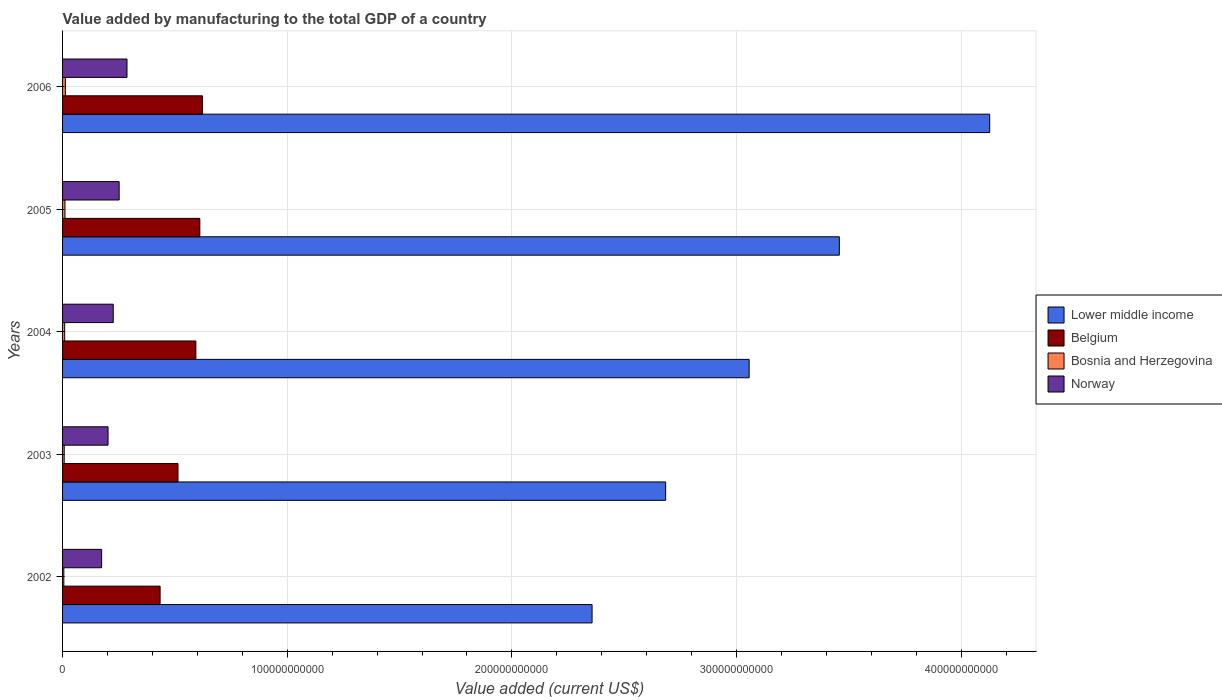Are the number of bars on each tick of the Y-axis equal?
Offer a very short reply. Yes. How many bars are there on the 3rd tick from the bottom?
Your answer should be compact. 4. In how many cases, is the number of bars for a given year not equal to the number of legend labels?
Keep it short and to the point. 0. What is the value added by manufacturing to the total GDP in Lower middle income in 2004?
Your response must be concise. 3.06e+11. Across all years, what is the maximum value added by manufacturing to the total GDP in Norway?
Your answer should be very brief. 2.87e+1. Across all years, what is the minimum value added by manufacturing to the total GDP in Bosnia and Herzegovina?
Make the answer very short. 5.59e+08. In which year was the value added by manufacturing to the total GDP in Bosnia and Herzegovina maximum?
Provide a succinct answer. 2006. What is the total value added by manufacturing to the total GDP in Norway in the graph?
Make the answer very short. 1.14e+11. What is the difference between the value added by manufacturing to the total GDP in Belgium in 2003 and that in 2006?
Your answer should be very brief. -1.09e+1. What is the difference between the value added by manufacturing to the total GDP in Norway in 2005 and the value added by manufacturing to the total GDP in Lower middle income in 2002?
Your response must be concise. -2.11e+11. What is the average value added by manufacturing to the total GDP in Bosnia and Herzegovina per year?
Offer a terse response. 9.12e+08. In the year 2004, what is the difference between the value added by manufacturing to the total GDP in Norway and value added by manufacturing to the total GDP in Belgium?
Your answer should be compact. -3.68e+1. What is the ratio of the value added by manufacturing to the total GDP in Lower middle income in 2003 to that in 2004?
Provide a short and direct response. 0.88. What is the difference between the highest and the second highest value added by manufacturing to the total GDP in Belgium?
Your response must be concise. 1.15e+09. What is the difference between the highest and the lowest value added by manufacturing to the total GDP in Lower middle income?
Ensure brevity in your answer.  1.77e+11. Is the sum of the value added by manufacturing to the total GDP in Belgium in 2003 and 2004 greater than the maximum value added by manufacturing to the total GDP in Bosnia and Herzegovina across all years?
Offer a terse response. Yes. Is it the case that in every year, the sum of the value added by manufacturing to the total GDP in Lower middle income and value added by manufacturing to the total GDP in Bosnia and Herzegovina is greater than the sum of value added by manufacturing to the total GDP in Norway and value added by manufacturing to the total GDP in Belgium?
Your answer should be compact. Yes. Are all the bars in the graph horizontal?
Your answer should be very brief. Yes. How many years are there in the graph?
Your answer should be compact. 5. What is the difference between two consecutive major ticks on the X-axis?
Offer a terse response. 1.00e+11. Does the graph contain any zero values?
Give a very brief answer. No. Where does the legend appear in the graph?
Offer a very short reply. Center right. How are the legend labels stacked?
Offer a very short reply. Vertical. What is the title of the graph?
Provide a short and direct response. Value added by manufacturing to the total GDP of a country. What is the label or title of the X-axis?
Offer a terse response. Value added (current US$). What is the Value added (current US$) of Lower middle income in 2002?
Offer a terse response. 2.36e+11. What is the Value added (current US$) of Belgium in 2002?
Keep it short and to the point. 4.34e+1. What is the Value added (current US$) in Bosnia and Herzegovina in 2002?
Offer a very short reply. 5.59e+08. What is the Value added (current US$) of Norway in 2002?
Provide a short and direct response. 1.74e+1. What is the Value added (current US$) of Lower middle income in 2003?
Your response must be concise. 2.68e+11. What is the Value added (current US$) in Belgium in 2003?
Keep it short and to the point. 5.14e+1. What is the Value added (current US$) in Bosnia and Herzegovina in 2003?
Ensure brevity in your answer.  7.27e+08. What is the Value added (current US$) of Norway in 2003?
Give a very brief answer. 2.02e+1. What is the Value added (current US$) in Lower middle income in 2004?
Provide a short and direct response. 3.06e+11. What is the Value added (current US$) of Belgium in 2004?
Provide a short and direct response. 5.93e+1. What is the Value added (current US$) in Bosnia and Herzegovina in 2004?
Ensure brevity in your answer.  9.40e+08. What is the Value added (current US$) in Norway in 2004?
Give a very brief answer. 2.26e+1. What is the Value added (current US$) of Lower middle income in 2005?
Provide a short and direct response. 3.46e+11. What is the Value added (current US$) of Belgium in 2005?
Ensure brevity in your answer.  6.11e+1. What is the Value added (current US$) in Bosnia and Herzegovina in 2005?
Your answer should be compact. 1.08e+09. What is the Value added (current US$) in Norway in 2005?
Your answer should be compact. 2.52e+1. What is the Value added (current US$) of Lower middle income in 2006?
Your answer should be very brief. 4.13e+11. What is the Value added (current US$) in Belgium in 2006?
Provide a succinct answer. 6.22e+1. What is the Value added (current US$) in Bosnia and Herzegovina in 2006?
Make the answer very short. 1.25e+09. What is the Value added (current US$) in Norway in 2006?
Give a very brief answer. 2.87e+1. Across all years, what is the maximum Value added (current US$) of Lower middle income?
Provide a short and direct response. 4.13e+11. Across all years, what is the maximum Value added (current US$) of Belgium?
Offer a terse response. 6.22e+1. Across all years, what is the maximum Value added (current US$) of Bosnia and Herzegovina?
Give a very brief answer. 1.25e+09. Across all years, what is the maximum Value added (current US$) of Norway?
Ensure brevity in your answer.  2.87e+1. Across all years, what is the minimum Value added (current US$) of Lower middle income?
Your response must be concise. 2.36e+11. Across all years, what is the minimum Value added (current US$) in Belgium?
Your response must be concise. 4.34e+1. Across all years, what is the minimum Value added (current US$) in Bosnia and Herzegovina?
Offer a very short reply. 5.59e+08. Across all years, what is the minimum Value added (current US$) of Norway?
Give a very brief answer. 1.74e+1. What is the total Value added (current US$) in Lower middle income in the graph?
Your answer should be compact. 1.57e+12. What is the total Value added (current US$) of Belgium in the graph?
Your response must be concise. 2.77e+11. What is the total Value added (current US$) in Bosnia and Herzegovina in the graph?
Give a very brief answer. 4.56e+09. What is the total Value added (current US$) of Norway in the graph?
Keep it short and to the point. 1.14e+11. What is the difference between the Value added (current US$) of Lower middle income in 2002 and that in 2003?
Your response must be concise. -3.27e+1. What is the difference between the Value added (current US$) in Belgium in 2002 and that in 2003?
Keep it short and to the point. -7.96e+09. What is the difference between the Value added (current US$) in Bosnia and Herzegovina in 2002 and that in 2003?
Offer a very short reply. -1.68e+08. What is the difference between the Value added (current US$) of Norway in 2002 and that in 2003?
Provide a short and direct response. -2.85e+09. What is the difference between the Value added (current US$) of Lower middle income in 2002 and that in 2004?
Offer a very short reply. -6.99e+1. What is the difference between the Value added (current US$) in Belgium in 2002 and that in 2004?
Offer a terse response. -1.59e+1. What is the difference between the Value added (current US$) of Bosnia and Herzegovina in 2002 and that in 2004?
Your answer should be compact. -3.81e+08. What is the difference between the Value added (current US$) in Norway in 2002 and that in 2004?
Ensure brevity in your answer.  -5.17e+09. What is the difference between the Value added (current US$) of Lower middle income in 2002 and that in 2005?
Your answer should be very brief. -1.10e+11. What is the difference between the Value added (current US$) in Belgium in 2002 and that in 2005?
Provide a succinct answer. -1.77e+1. What is the difference between the Value added (current US$) in Bosnia and Herzegovina in 2002 and that in 2005?
Offer a very short reply. -5.20e+08. What is the difference between the Value added (current US$) in Norway in 2002 and that in 2005?
Offer a terse response. -7.80e+09. What is the difference between the Value added (current US$) in Lower middle income in 2002 and that in 2006?
Provide a succinct answer. -1.77e+11. What is the difference between the Value added (current US$) in Belgium in 2002 and that in 2006?
Your answer should be very brief. -1.88e+1. What is the difference between the Value added (current US$) of Bosnia and Herzegovina in 2002 and that in 2006?
Ensure brevity in your answer.  -6.96e+08. What is the difference between the Value added (current US$) of Norway in 2002 and that in 2006?
Your answer should be compact. -1.13e+1. What is the difference between the Value added (current US$) of Lower middle income in 2003 and that in 2004?
Give a very brief answer. -3.72e+1. What is the difference between the Value added (current US$) of Belgium in 2003 and that in 2004?
Your response must be concise. -7.95e+09. What is the difference between the Value added (current US$) in Bosnia and Herzegovina in 2003 and that in 2004?
Your response must be concise. -2.13e+08. What is the difference between the Value added (current US$) in Norway in 2003 and that in 2004?
Provide a short and direct response. -2.31e+09. What is the difference between the Value added (current US$) in Lower middle income in 2003 and that in 2005?
Your response must be concise. -7.73e+1. What is the difference between the Value added (current US$) in Belgium in 2003 and that in 2005?
Offer a very short reply. -9.71e+09. What is the difference between the Value added (current US$) of Bosnia and Herzegovina in 2003 and that in 2005?
Provide a succinct answer. -3.52e+08. What is the difference between the Value added (current US$) of Norway in 2003 and that in 2005?
Ensure brevity in your answer.  -4.94e+09. What is the difference between the Value added (current US$) in Lower middle income in 2003 and that in 2006?
Ensure brevity in your answer.  -1.44e+11. What is the difference between the Value added (current US$) of Belgium in 2003 and that in 2006?
Your answer should be compact. -1.09e+1. What is the difference between the Value added (current US$) of Bosnia and Herzegovina in 2003 and that in 2006?
Your response must be concise. -5.28e+08. What is the difference between the Value added (current US$) in Norway in 2003 and that in 2006?
Your answer should be very brief. -8.43e+09. What is the difference between the Value added (current US$) in Lower middle income in 2004 and that in 2005?
Offer a terse response. -4.01e+1. What is the difference between the Value added (current US$) of Belgium in 2004 and that in 2005?
Your answer should be very brief. -1.77e+09. What is the difference between the Value added (current US$) in Bosnia and Herzegovina in 2004 and that in 2005?
Offer a terse response. -1.40e+08. What is the difference between the Value added (current US$) in Norway in 2004 and that in 2005?
Offer a very short reply. -2.63e+09. What is the difference between the Value added (current US$) in Lower middle income in 2004 and that in 2006?
Offer a terse response. -1.07e+11. What is the difference between the Value added (current US$) of Belgium in 2004 and that in 2006?
Keep it short and to the point. -2.92e+09. What is the difference between the Value added (current US$) of Bosnia and Herzegovina in 2004 and that in 2006?
Your answer should be compact. -3.15e+08. What is the difference between the Value added (current US$) in Norway in 2004 and that in 2006?
Make the answer very short. -6.12e+09. What is the difference between the Value added (current US$) in Lower middle income in 2005 and that in 2006?
Keep it short and to the point. -6.69e+1. What is the difference between the Value added (current US$) in Belgium in 2005 and that in 2006?
Offer a very short reply. -1.15e+09. What is the difference between the Value added (current US$) in Bosnia and Herzegovina in 2005 and that in 2006?
Keep it short and to the point. -1.75e+08. What is the difference between the Value added (current US$) of Norway in 2005 and that in 2006?
Provide a succinct answer. -3.49e+09. What is the difference between the Value added (current US$) in Lower middle income in 2002 and the Value added (current US$) in Belgium in 2003?
Your answer should be very brief. 1.84e+11. What is the difference between the Value added (current US$) in Lower middle income in 2002 and the Value added (current US$) in Bosnia and Herzegovina in 2003?
Keep it short and to the point. 2.35e+11. What is the difference between the Value added (current US$) of Lower middle income in 2002 and the Value added (current US$) of Norway in 2003?
Give a very brief answer. 2.15e+11. What is the difference between the Value added (current US$) in Belgium in 2002 and the Value added (current US$) in Bosnia and Herzegovina in 2003?
Ensure brevity in your answer.  4.27e+1. What is the difference between the Value added (current US$) in Belgium in 2002 and the Value added (current US$) in Norway in 2003?
Your response must be concise. 2.32e+1. What is the difference between the Value added (current US$) in Bosnia and Herzegovina in 2002 and the Value added (current US$) in Norway in 2003?
Give a very brief answer. -1.97e+1. What is the difference between the Value added (current US$) of Lower middle income in 2002 and the Value added (current US$) of Belgium in 2004?
Offer a terse response. 1.76e+11. What is the difference between the Value added (current US$) in Lower middle income in 2002 and the Value added (current US$) in Bosnia and Herzegovina in 2004?
Your response must be concise. 2.35e+11. What is the difference between the Value added (current US$) of Lower middle income in 2002 and the Value added (current US$) of Norway in 2004?
Offer a very short reply. 2.13e+11. What is the difference between the Value added (current US$) of Belgium in 2002 and the Value added (current US$) of Bosnia and Herzegovina in 2004?
Give a very brief answer. 4.25e+1. What is the difference between the Value added (current US$) of Belgium in 2002 and the Value added (current US$) of Norway in 2004?
Offer a very short reply. 2.09e+1. What is the difference between the Value added (current US$) in Bosnia and Herzegovina in 2002 and the Value added (current US$) in Norway in 2004?
Make the answer very short. -2.20e+1. What is the difference between the Value added (current US$) in Lower middle income in 2002 and the Value added (current US$) in Belgium in 2005?
Provide a short and direct response. 1.75e+11. What is the difference between the Value added (current US$) of Lower middle income in 2002 and the Value added (current US$) of Bosnia and Herzegovina in 2005?
Your response must be concise. 2.35e+11. What is the difference between the Value added (current US$) in Lower middle income in 2002 and the Value added (current US$) in Norway in 2005?
Give a very brief answer. 2.11e+11. What is the difference between the Value added (current US$) of Belgium in 2002 and the Value added (current US$) of Bosnia and Herzegovina in 2005?
Offer a very short reply. 4.23e+1. What is the difference between the Value added (current US$) of Belgium in 2002 and the Value added (current US$) of Norway in 2005?
Offer a very short reply. 1.82e+1. What is the difference between the Value added (current US$) of Bosnia and Herzegovina in 2002 and the Value added (current US$) of Norway in 2005?
Make the answer very short. -2.46e+1. What is the difference between the Value added (current US$) in Lower middle income in 2002 and the Value added (current US$) in Belgium in 2006?
Your response must be concise. 1.73e+11. What is the difference between the Value added (current US$) in Lower middle income in 2002 and the Value added (current US$) in Bosnia and Herzegovina in 2006?
Give a very brief answer. 2.34e+11. What is the difference between the Value added (current US$) of Lower middle income in 2002 and the Value added (current US$) of Norway in 2006?
Your answer should be very brief. 2.07e+11. What is the difference between the Value added (current US$) in Belgium in 2002 and the Value added (current US$) in Bosnia and Herzegovina in 2006?
Your response must be concise. 4.22e+1. What is the difference between the Value added (current US$) of Belgium in 2002 and the Value added (current US$) of Norway in 2006?
Provide a short and direct response. 1.47e+1. What is the difference between the Value added (current US$) in Bosnia and Herzegovina in 2002 and the Value added (current US$) in Norway in 2006?
Provide a short and direct response. -2.81e+1. What is the difference between the Value added (current US$) in Lower middle income in 2003 and the Value added (current US$) in Belgium in 2004?
Give a very brief answer. 2.09e+11. What is the difference between the Value added (current US$) of Lower middle income in 2003 and the Value added (current US$) of Bosnia and Herzegovina in 2004?
Ensure brevity in your answer.  2.68e+11. What is the difference between the Value added (current US$) of Lower middle income in 2003 and the Value added (current US$) of Norway in 2004?
Give a very brief answer. 2.46e+11. What is the difference between the Value added (current US$) of Belgium in 2003 and the Value added (current US$) of Bosnia and Herzegovina in 2004?
Your answer should be compact. 5.04e+1. What is the difference between the Value added (current US$) of Belgium in 2003 and the Value added (current US$) of Norway in 2004?
Provide a short and direct response. 2.88e+1. What is the difference between the Value added (current US$) in Bosnia and Herzegovina in 2003 and the Value added (current US$) in Norway in 2004?
Offer a very short reply. -2.18e+1. What is the difference between the Value added (current US$) in Lower middle income in 2003 and the Value added (current US$) in Belgium in 2005?
Make the answer very short. 2.07e+11. What is the difference between the Value added (current US$) in Lower middle income in 2003 and the Value added (current US$) in Bosnia and Herzegovina in 2005?
Provide a succinct answer. 2.67e+11. What is the difference between the Value added (current US$) in Lower middle income in 2003 and the Value added (current US$) in Norway in 2005?
Make the answer very short. 2.43e+11. What is the difference between the Value added (current US$) of Belgium in 2003 and the Value added (current US$) of Bosnia and Herzegovina in 2005?
Your answer should be compact. 5.03e+1. What is the difference between the Value added (current US$) in Belgium in 2003 and the Value added (current US$) in Norway in 2005?
Keep it short and to the point. 2.62e+1. What is the difference between the Value added (current US$) in Bosnia and Herzegovina in 2003 and the Value added (current US$) in Norway in 2005?
Offer a terse response. -2.45e+1. What is the difference between the Value added (current US$) in Lower middle income in 2003 and the Value added (current US$) in Belgium in 2006?
Ensure brevity in your answer.  2.06e+11. What is the difference between the Value added (current US$) in Lower middle income in 2003 and the Value added (current US$) in Bosnia and Herzegovina in 2006?
Your response must be concise. 2.67e+11. What is the difference between the Value added (current US$) in Lower middle income in 2003 and the Value added (current US$) in Norway in 2006?
Give a very brief answer. 2.40e+11. What is the difference between the Value added (current US$) of Belgium in 2003 and the Value added (current US$) of Bosnia and Herzegovina in 2006?
Your response must be concise. 5.01e+1. What is the difference between the Value added (current US$) in Belgium in 2003 and the Value added (current US$) in Norway in 2006?
Give a very brief answer. 2.27e+1. What is the difference between the Value added (current US$) in Bosnia and Herzegovina in 2003 and the Value added (current US$) in Norway in 2006?
Ensure brevity in your answer.  -2.80e+1. What is the difference between the Value added (current US$) in Lower middle income in 2004 and the Value added (current US$) in Belgium in 2005?
Offer a very short reply. 2.45e+11. What is the difference between the Value added (current US$) of Lower middle income in 2004 and the Value added (current US$) of Bosnia and Herzegovina in 2005?
Keep it short and to the point. 3.05e+11. What is the difference between the Value added (current US$) in Lower middle income in 2004 and the Value added (current US$) in Norway in 2005?
Keep it short and to the point. 2.80e+11. What is the difference between the Value added (current US$) of Belgium in 2004 and the Value added (current US$) of Bosnia and Herzegovina in 2005?
Give a very brief answer. 5.83e+1. What is the difference between the Value added (current US$) of Belgium in 2004 and the Value added (current US$) of Norway in 2005?
Your answer should be very brief. 3.41e+1. What is the difference between the Value added (current US$) in Bosnia and Herzegovina in 2004 and the Value added (current US$) in Norway in 2005?
Ensure brevity in your answer.  -2.42e+1. What is the difference between the Value added (current US$) of Lower middle income in 2004 and the Value added (current US$) of Belgium in 2006?
Make the answer very short. 2.43e+11. What is the difference between the Value added (current US$) of Lower middle income in 2004 and the Value added (current US$) of Bosnia and Herzegovina in 2006?
Provide a succinct answer. 3.04e+11. What is the difference between the Value added (current US$) in Lower middle income in 2004 and the Value added (current US$) in Norway in 2006?
Provide a short and direct response. 2.77e+11. What is the difference between the Value added (current US$) in Belgium in 2004 and the Value added (current US$) in Bosnia and Herzegovina in 2006?
Offer a terse response. 5.81e+1. What is the difference between the Value added (current US$) in Belgium in 2004 and the Value added (current US$) in Norway in 2006?
Ensure brevity in your answer.  3.07e+1. What is the difference between the Value added (current US$) in Bosnia and Herzegovina in 2004 and the Value added (current US$) in Norway in 2006?
Your response must be concise. -2.77e+1. What is the difference between the Value added (current US$) in Lower middle income in 2005 and the Value added (current US$) in Belgium in 2006?
Make the answer very short. 2.84e+11. What is the difference between the Value added (current US$) in Lower middle income in 2005 and the Value added (current US$) in Bosnia and Herzegovina in 2006?
Ensure brevity in your answer.  3.45e+11. What is the difference between the Value added (current US$) of Lower middle income in 2005 and the Value added (current US$) of Norway in 2006?
Your answer should be compact. 3.17e+11. What is the difference between the Value added (current US$) in Belgium in 2005 and the Value added (current US$) in Bosnia and Herzegovina in 2006?
Your answer should be compact. 5.98e+1. What is the difference between the Value added (current US$) of Belgium in 2005 and the Value added (current US$) of Norway in 2006?
Offer a very short reply. 3.24e+1. What is the difference between the Value added (current US$) in Bosnia and Herzegovina in 2005 and the Value added (current US$) in Norway in 2006?
Provide a succinct answer. -2.76e+1. What is the average Value added (current US$) in Lower middle income per year?
Your answer should be compact. 3.14e+11. What is the average Value added (current US$) in Belgium per year?
Your answer should be very brief. 5.55e+1. What is the average Value added (current US$) of Bosnia and Herzegovina per year?
Your answer should be compact. 9.12e+08. What is the average Value added (current US$) in Norway per year?
Your answer should be compact. 2.28e+1. In the year 2002, what is the difference between the Value added (current US$) of Lower middle income and Value added (current US$) of Belgium?
Provide a succinct answer. 1.92e+11. In the year 2002, what is the difference between the Value added (current US$) of Lower middle income and Value added (current US$) of Bosnia and Herzegovina?
Offer a very short reply. 2.35e+11. In the year 2002, what is the difference between the Value added (current US$) of Lower middle income and Value added (current US$) of Norway?
Your answer should be compact. 2.18e+11. In the year 2002, what is the difference between the Value added (current US$) of Belgium and Value added (current US$) of Bosnia and Herzegovina?
Offer a terse response. 4.29e+1. In the year 2002, what is the difference between the Value added (current US$) in Belgium and Value added (current US$) in Norway?
Offer a terse response. 2.60e+1. In the year 2002, what is the difference between the Value added (current US$) of Bosnia and Herzegovina and Value added (current US$) of Norway?
Provide a short and direct response. -1.68e+1. In the year 2003, what is the difference between the Value added (current US$) in Lower middle income and Value added (current US$) in Belgium?
Offer a very short reply. 2.17e+11. In the year 2003, what is the difference between the Value added (current US$) of Lower middle income and Value added (current US$) of Bosnia and Herzegovina?
Give a very brief answer. 2.68e+11. In the year 2003, what is the difference between the Value added (current US$) of Lower middle income and Value added (current US$) of Norway?
Offer a terse response. 2.48e+11. In the year 2003, what is the difference between the Value added (current US$) in Belgium and Value added (current US$) in Bosnia and Herzegovina?
Keep it short and to the point. 5.07e+1. In the year 2003, what is the difference between the Value added (current US$) in Belgium and Value added (current US$) in Norway?
Your answer should be compact. 3.11e+1. In the year 2003, what is the difference between the Value added (current US$) in Bosnia and Herzegovina and Value added (current US$) in Norway?
Ensure brevity in your answer.  -1.95e+1. In the year 2004, what is the difference between the Value added (current US$) in Lower middle income and Value added (current US$) in Belgium?
Give a very brief answer. 2.46e+11. In the year 2004, what is the difference between the Value added (current US$) of Lower middle income and Value added (current US$) of Bosnia and Herzegovina?
Offer a very short reply. 3.05e+11. In the year 2004, what is the difference between the Value added (current US$) of Lower middle income and Value added (current US$) of Norway?
Your response must be concise. 2.83e+11. In the year 2004, what is the difference between the Value added (current US$) in Belgium and Value added (current US$) in Bosnia and Herzegovina?
Keep it short and to the point. 5.84e+1. In the year 2004, what is the difference between the Value added (current US$) in Belgium and Value added (current US$) in Norway?
Your response must be concise. 3.68e+1. In the year 2004, what is the difference between the Value added (current US$) of Bosnia and Herzegovina and Value added (current US$) of Norway?
Offer a terse response. -2.16e+1. In the year 2005, what is the difference between the Value added (current US$) in Lower middle income and Value added (current US$) in Belgium?
Give a very brief answer. 2.85e+11. In the year 2005, what is the difference between the Value added (current US$) of Lower middle income and Value added (current US$) of Bosnia and Herzegovina?
Offer a terse response. 3.45e+11. In the year 2005, what is the difference between the Value added (current US$) in Lower middle income and Value added (current US$) in Norway?
Make the answer very short. 3.21e+11. In the year 2005, what is the difference between the Value added (current US$) of Belgium and Value added (current US$) of Bosnia and Herzegovina?
Keep it short and to the point. 6.00e+1. In the year 2005, what is the difference between the Value added (current US$) of Belgium and Value added (current US$) of Norway?
Ensure brevity in your answer.  3.59e+1. In the year 2005, what is the difference between the Value added (current US$) of Bosnia and Herzegovina and Value added (current US$) of Norway?
Make the answer very short. -2.41e+1. In the year 2006, what is the difference between the Value added (current US$) in Lower middle income and Value added (current US$) in Belgium?
Offer a very short reply. 3.50e+11. In the year 2006, what is the difference between the Value added (current US$) in Lower middle income and Value added (current US$) in Bosnia and Herzegovina?
Make the answer very short. 4.11e+11. In the year 2006, what is the difference between the Value added (current US$) in Lower middle income and Value added (current US$) in Norway?
Provide a short and direct response. 3.84e+11. In the year 2006, what is the difference between the Value added (current US$) of Belgium and Value added (current US$) of Bosnia and Herzegovina?
Offer a very short reply. 6.10e+1. In the year 2006, what is the difference between the Value added (current US$) in Belgium and Value added (current US$) in Norway?
Offer a very short reply. 3.36e+1. In the year 2006, what is the difference between the Value added (current US$) of Bosnia and Herzegovina and Value added (current US$) of Norway?
Your answer should be very brief. -2.74e+1. What is the ratio of the Value added (current US$) of Lower middle income in 2002 to that in 2003?
Ensure brevity in your answer.  0.88. What is the ratio of the Value added (current US$) in Belgium in 2002 to that in 2003?
Keep it short and to the point. 0.85. What is the ratio of the Value added (current US$) of Bosnia and Herzegovina in 2002 to that in 2003?
Offer a terse response. 0.77. What is the ratio of the Value added (current US$) in Norway in 2002 to that in 2003?
Provide a succinct answer. 0.86. What is the ratio of the Value added (current US$) in Lower middle income in 2002 to that in 2004?
Offer a very short reply. 0.77. What is the ratio of the Value added (current US$) in Belgium in 2002 to that in 2004?
Ensure brevity in your answer.  0.73. What is the ratio of the Value added (current US$) in Bosnia and Herzegovina in 2002 to that in 2004?
Keep it short and to the point. 0.59. What is the ratio of the Value added (current US$) of Norway in 2002 to that in 2004?
Ensure brevity in your answer.  0.77. What is the ratio of the Value added (current US$) of Lower middle income in 2002 to that in 2005?
Ensure brevity in your answer.  0.68. What is the ratio of the Value added (current US$) in Belgium in 2002 to that in 2005?
Provide a succinct answer. 0.71. What is the ratio of the Value added (current US$) of Bosnia and Herzegovina in 2002 to that in 2005?
Keep it short and to the point. 0.52. What is the ratio of the Value added (current US$) in Norway in 2002 to that in 2005?
Provide a succinct answer. 0.69. What is the ratio of the Value added (current US$) of Lower middle income in 2002 to that in 2006?
Your answer should be very brief. 0.57. What is the ratio of the Value added (current US$) in Belgium in 2002 to that in 2006?
Your response must be concise. 0.7. What is the ratio of the Value added (current US$) of Bosnia and Herzegovina in 2002 to that in 2006?
Make the answer very short. 0.45. What is the ratio of the Value added (current US$) in Norway in 2002 to that in 2006?
Ensure brevity in your answer.  0.61. What is the ratio of the Value added (current US$) of Lower middle income in 2003 to that in 2004?
Ensure brevity in your answer.  0.88. What is the ratio of the Value added (current US$) in Belgium in 2003 to that in 2004?
Offer a terse response. 0.87. What is the ratio of the Value added (current US$) of Bosnia and Herzegovina in 2003 to that in 2004?
Your response must be concise. 0.77. What is the ratio of the Value added (current US$) in Norway in 2003 to that in 2004?
Your answer should be very brief. 0.9. What is the ratio of the Value added (current US$) in Lower middle income in 2003 to that in 2005?
Your answer should be compact. 0.78. What is the ratio of the Value added (current US$) of Belgium in 2003 to that in 2005?
Provide a succinct answer. 0.84. What is the ratio of the Value added (current US$) of Bosnia and Herzegovina in 2003 to that in 2005?
Offer a very short reply. 0.67. What is the ratio of the Value added (current US$) of Norway in 2003 to that in 2005?
Give a very brief answer. 0.8. What is the ratio of the Value added (current US$) in Lower middle income in 2003 to that in 2006?
Your answer should be very brief. 0.65. What is the ratio of the Value added (current US$) in Belgium in 2003 to that in 2006?
Make the answer very short. 0.83. What is the ratio of the Value added (current US$) in Bosnia and Herzegovina in 2003 to that in 2006?
Offer a terse response. 0.58. What is the ratio of the Value added (current US$) in Norway in 2003 to that in 2006?
Make the answer very short. 0.71. What is the ratio of the Value added (current US$) in Lower middle income in 2004 to that in 2005?
Offer a terse response. 0.88. What is the ratio of the Value added (current US$) of Belgium in 2004 to that in 2005?
Provide a succinct answer. 0.97. What is the ratio of the Value added (current US$) of Bosnia and Herzegovina in 2004 to that in 2005?
Offer a very short reply. 0.87. What is the ratio of the Value added (current US$) of Norway in 2004 to that in 2005?
Provide a short and direct response. 0.9. What is the ratio of the Value added (current US$) in Lower middle income in 2004 to that in 2006?
Make the answer very short. 0.74. What is the ratio of the Value added (current US$) in Belgium in 2004 to that in 2006?
Ensure brevity in your answer.  0.95. What is the ratio of the Value added (current US$) in Bosnia and Herzegovina in 2004 to that in 2006?
Ensure brevity in your answer.  0.75. What is the ratio of the Value added (current US$) in Norway in 2004 to that in 2006?
Provide a succinct answer. 0.79. What is the ratio of the Value added (current US$) of Lower middle income in 2005 to that in 2006?
Provide a short and direct response. 0.84. What is the ratio of the Value added (current US$) in Belgium in 2005 to that in 2006?
Keep it short and to the point. 0.98. What is the ratio of the Value added (current US$) of Bosnia and Herzegovina in 2005 to that in 2006?
Ensure brevity in your answer.  0.86. What is the ratio of the Value added (current US$) in Norway in 2005 to that in 2006?
Ensure brevity in your answer.  0.88. What is the difference between the highest and the second highest Value added (current US$) of Lower middle income?
Offer a very short reply. 6.69e+1. What is the difference between the highest and the second highest Value added (current US$) in Belgium?
Provide a succinct answer. 1.15e+09. What is the difference between the highest and the second highest Value added (current US$) in Bosnia and Herzegovina?
Your response must be concise. 1.75e+08. What is the difference between the highest and the second highest Value added (current US$) in Norway?
Make the answer very short. 3.49e+09. What is the difference between the highest and the lowest Value added (current US$) in Lower middle income?
Make the answer very short. 1.77e+11. What is the difference between the highest and the lowest Value added (current US$) of Belgium?
Provide a short and direct response. 1.88e+1. What is the difference between the highest and the lowest Value added (current US$) of Bosnia and Herzegovina?
Your response must be concise. 6.96e+08. What is the difference between the highest and the lowest Value added (current US$) in Norway?
Provide a short and direct response. 1.13e+1. 